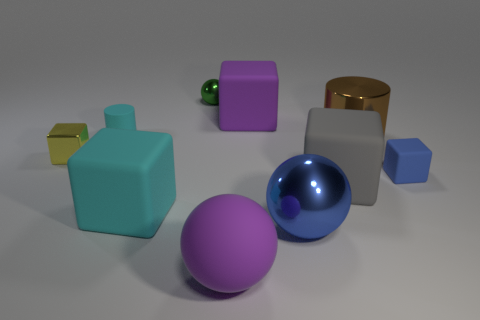What is the size of the blue matte object?
Provide a short and direct response. Small. How many cyan matte cylinders have the same size as the blue block?
Keep it short and to the point. 1. Are the cylinder that is right of the big blue metal sphere and the blue thing right of the large metal cylinder made of the same material?
Offer a very short reply. No. What is the material of the thing left of the cyan matte thing that is behind the brown metallic cylinder?
Provide a short and direct response. Metal. There is a big blue sphere that is on the left side of the brown metal cylinder; what material is it?
Keep it short and to the point. Metal. How many big green rubber objects are the same shape as the tiny green object?
Your answer should be compact. 0. Is the small metallic block the same color as the small rubber block?
Provide a succinct answer. No. What is the big purple thing left of the large purple matte object behind the metal block in front of the cyan cylinder made of?
Provide a short and direct response. Rubber. There is a metallic cylinder; are there any blue balls behind it?
Offer a very short reply. No. What is the shape of the cyan matte object that is the same size as the gray cube?
Your answer should be compact. Cube. 